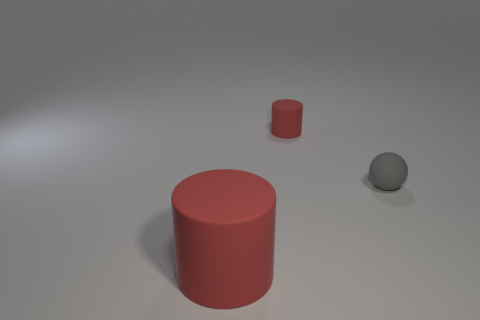Add 3 red rubber things. How many objects exist? 6 Subtract all cylinders. How many objects are left? 1 Subtract all big red things. Subtract all tiny red cylinders. How many objects are left? 1 Add 1 big red matte objects. How many big red matte objects are left? 2 Add 1 large red cylinders. How many large red cylinders exist? 2 Subtract 0 cyan balls. How many objects are left? 3 